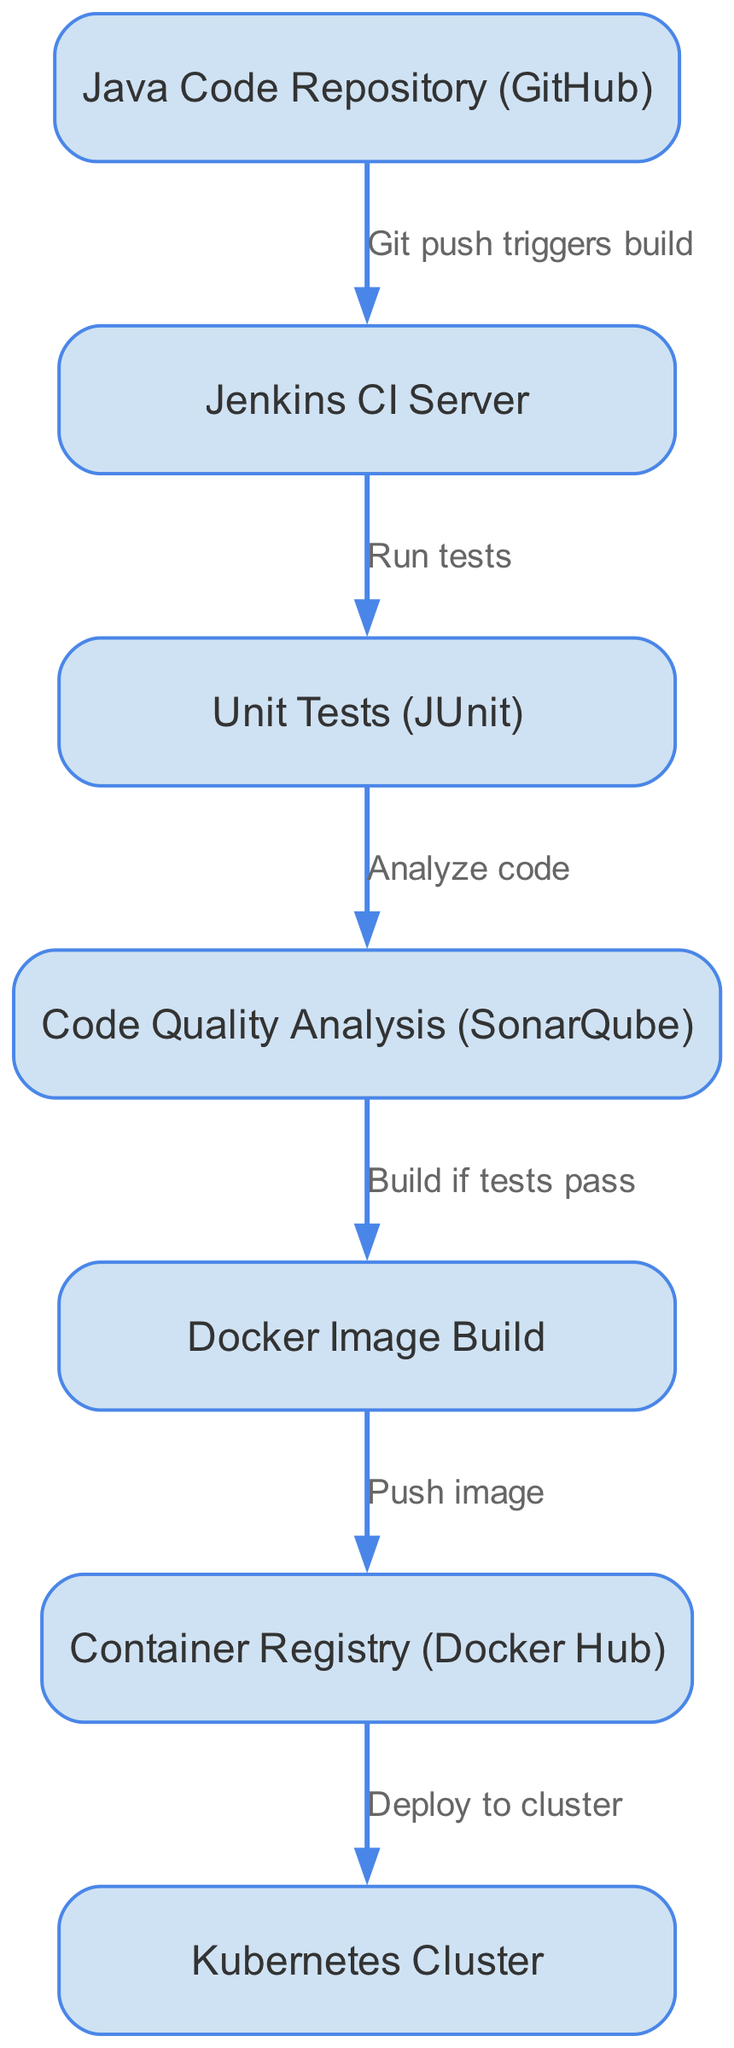What triggers the build process? The build process is triggered by a "Git push" event coming from the Java Code Repository in GitHub. This is clearly indicated by the edge labeled "Git push triggers build" connecting the Java Code Repository to the Jenkins CI Server.
Answer: Git push How many nodes are present in the diagram? The diagram contains a total of 7 distinct nodes that represent various stages of the CI/CD pipeline. These nodes include the Java Code Repository, Jenkins CI Server, Unit Tests, Code Quality Analysis, Docker Image Build, Container Registry, and Kubernetes Cluster.
Answer: 7 What is the first step in the CI/CD pipeline? The first step in the CI/CD pipeline is the "Java Code Repository (GitHub)," which initiates the process when a change is pushed to the repository.
Answer: Java Code Repository (GitHub) Which tool is used for code quality analysis? The tool used for code quality analysis in this pipeline is "SonarQube," which follows the Unit Tests step, as represented by the edge leading to it.
Answer: SonarQube What happens after the unit tests are run? After the unit tests are run, the next action is to analyze the code, as indicated by the edge leading from Unit Tests to Code Quality Analysis.
Answer: Analyze code If the tests fail, what happens next? If the tests fail, the diagram does not specify any further action as the edge leading to "Build if tests pass" indicates that the build action only occurs if the tests pass. Therefore, no specific step is shown for the failure scenario.
Answer: No action specified What is the final deployment stage in the CI/CD pipeline? The final deployment stage in the CI/CD pipeline is the "Kubernetes Cluster," which receives the Docker image from the Container Registry as the last step in the described flow.
Answer: Kubernetes Cluster 